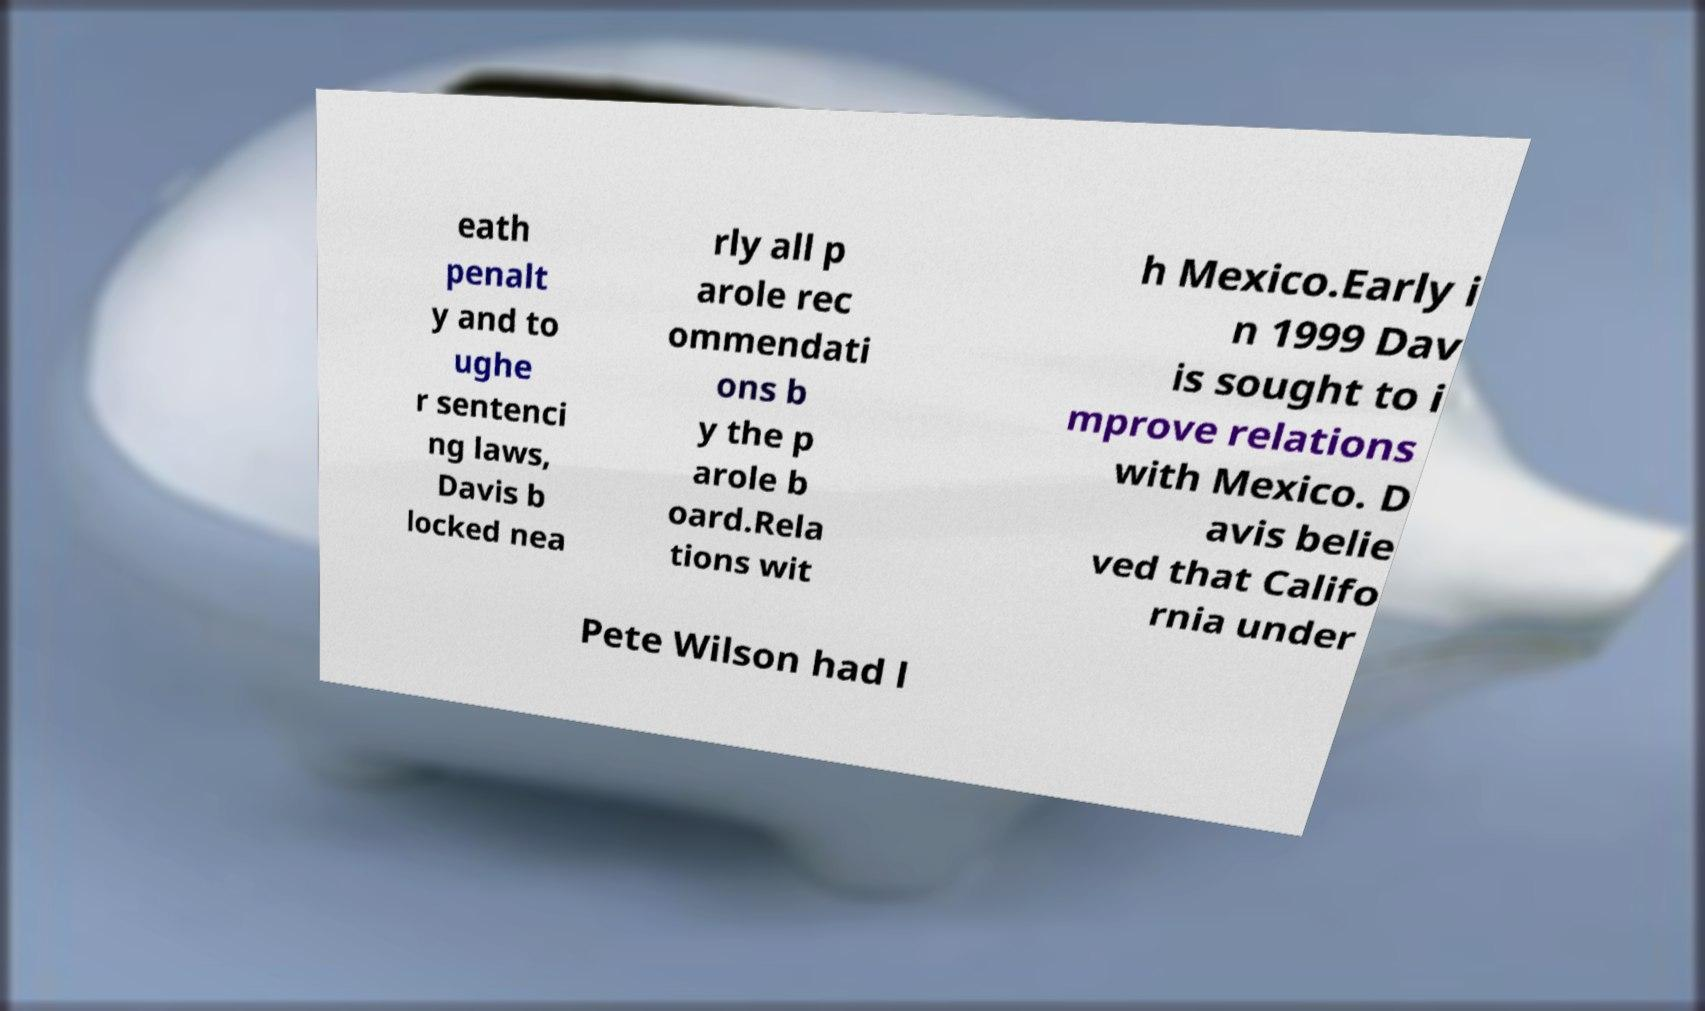Can you accurately transcribe the text from the provided image for me? eath penalt y and to ughe r sentenci ng laws, Davis b locked nea rly all p arole rec ommendati ons b y the p arole b oard.Rela tions wit h Mexico.Early i n 1999 Dav is sought to i mprove relations with Mexico. D avis belie ved that Califo rnia under Pete Wilson had l 